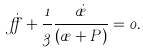Convert formula to latex. <formula><loc_0><loc_0><loc_500><loc_500>\dot { \alpha } + \frac { 1 } { 3 } \frac { \dot { \rho } } { \left ( \rho + P \right ) } = 0 .</formula> 